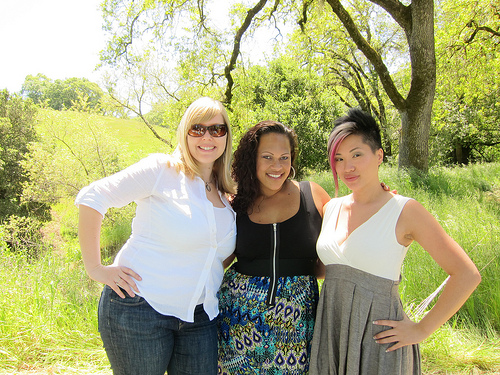<image>
Is there a woman to the left of the tree? Yes. From this viewpoint, the woman is positioned to the left side relative to the tree. Where is the big girl in relation to the small girl? Is it to the right of the small girl? Yes. From this viewpoint, the big girl is positioned to the right side relative to the small girl. Is there a woman to the right of the tree? No. The woman is not to the right of the tree. The horizontal positioning shows a different relationship. 